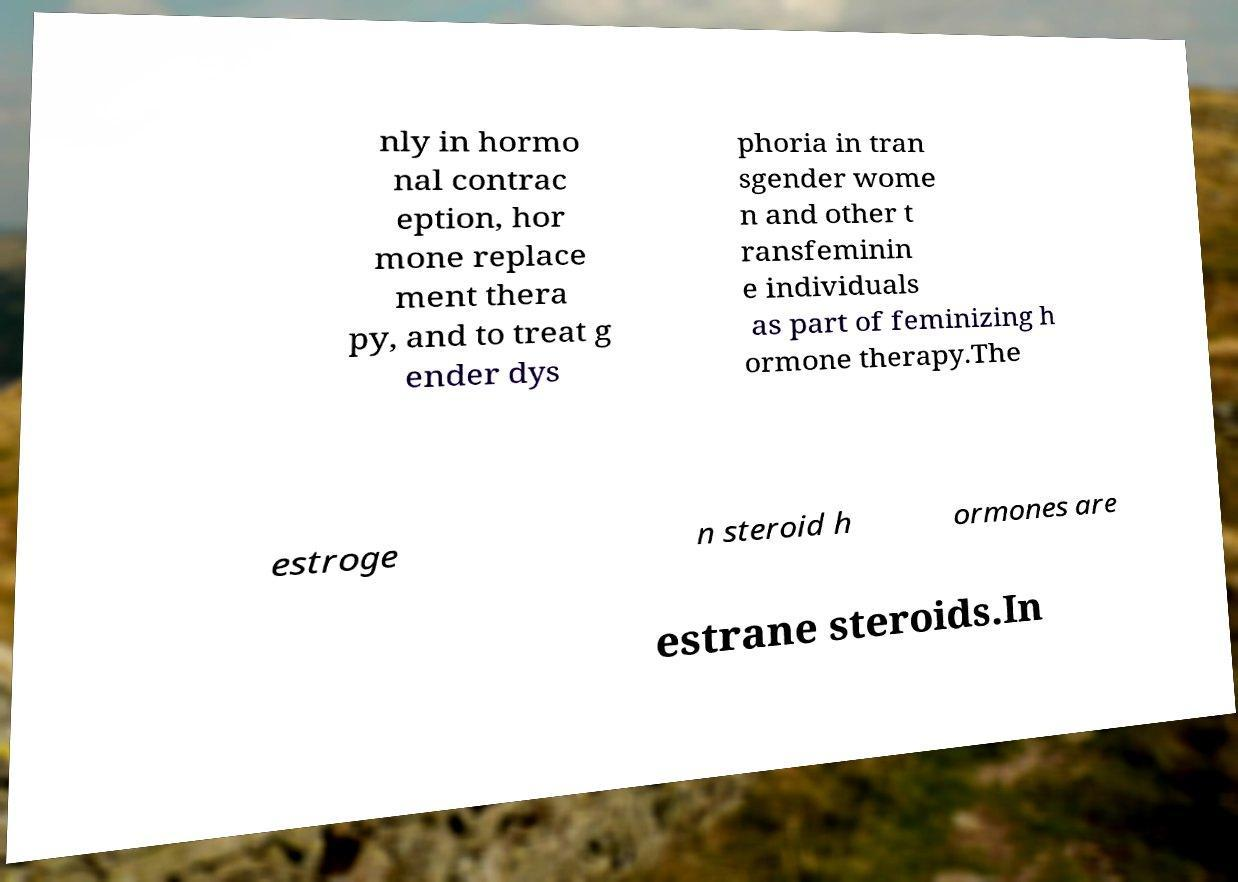Could you extract and type out the text from this image? nly in hormo nal contrac eption, hor mone replace ment thera py, and to treat g ender dys phoria in tran sgender wome n and other t ransfeminin e individuals as part of feminizing h ormone therapy.The estroge n steroid h ormones are estrane steroids.In 